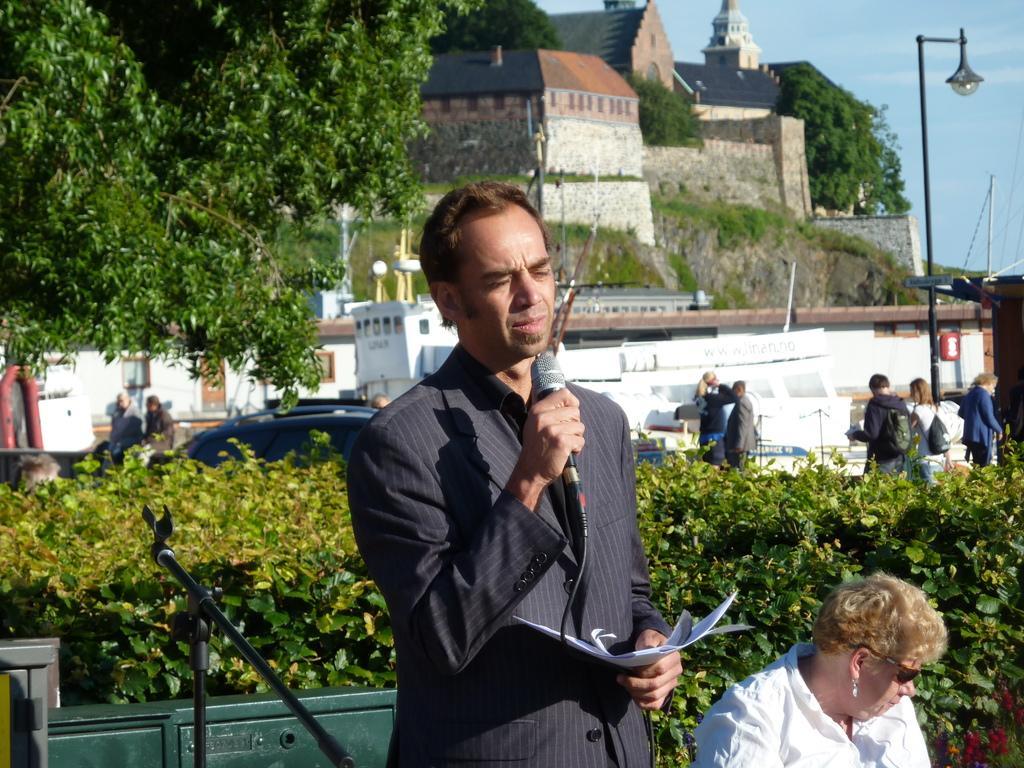Describe this image in one or two sentences. This is an outside view. Here I can see a man wearing a suit, holding some papers and mike in the hands and standing. Beside him there is another person wearing white color shirt and sitting. On the left side there is a metal object and also there is a mike stand. At the back of these people I can see few plants. In the background there is a car, few houses and people are standing and also I can see the trees. At the top of the image I can see the sky. On the right side there is a light pole. 